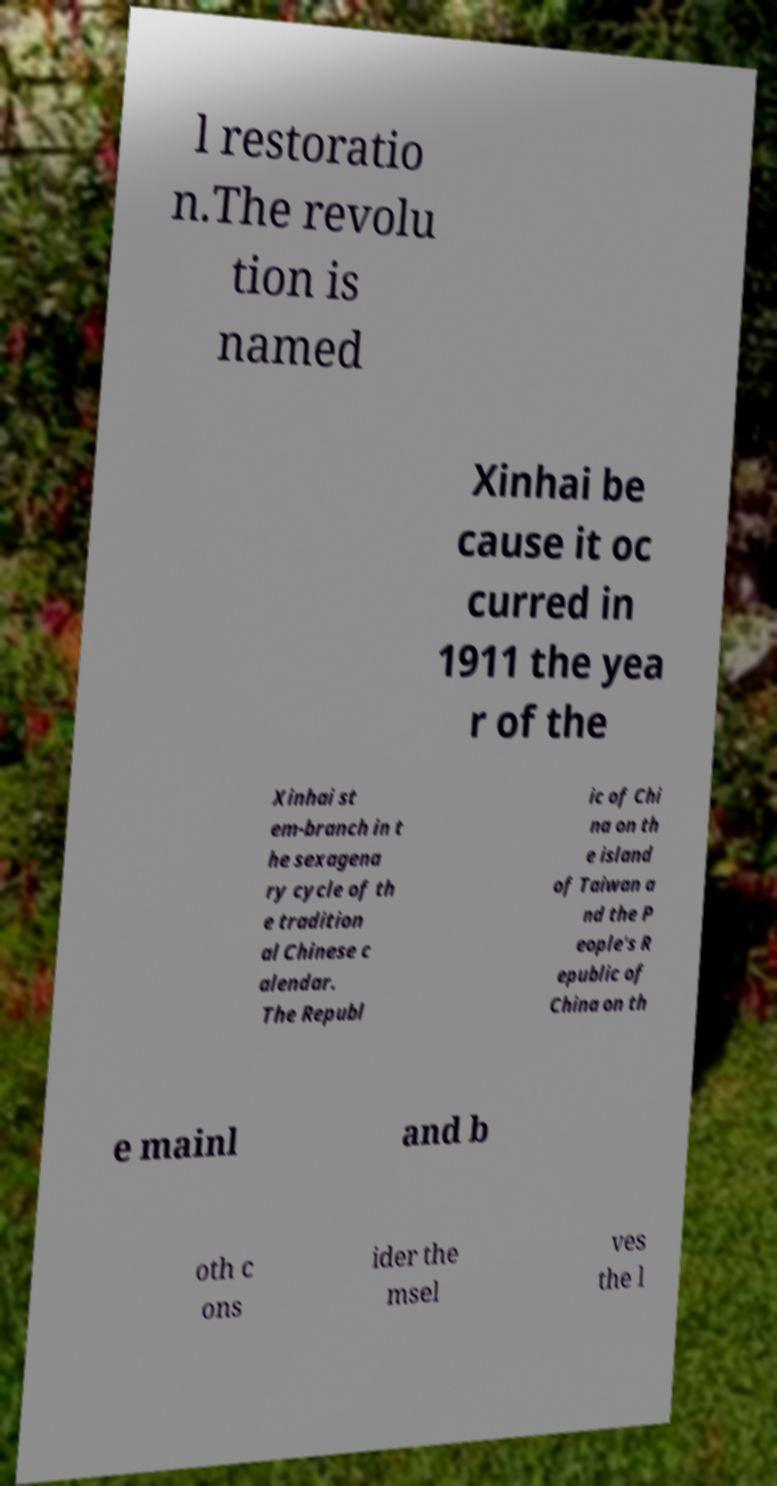Can you accurately transcribe the text from the provided image for me? l restoratio n.The revolu tion is named Xinhai be cause it oc curred in 1911 the yea r of the Xinhai st em-branch in t he sexagena ry cycle of th e tradition al Chinese c alendar. The Republ ic of Chi na on th e island of Taiwan a nd the P eople's R epublic of China on th e mainl and b oth c ons ider the msel ves the l 